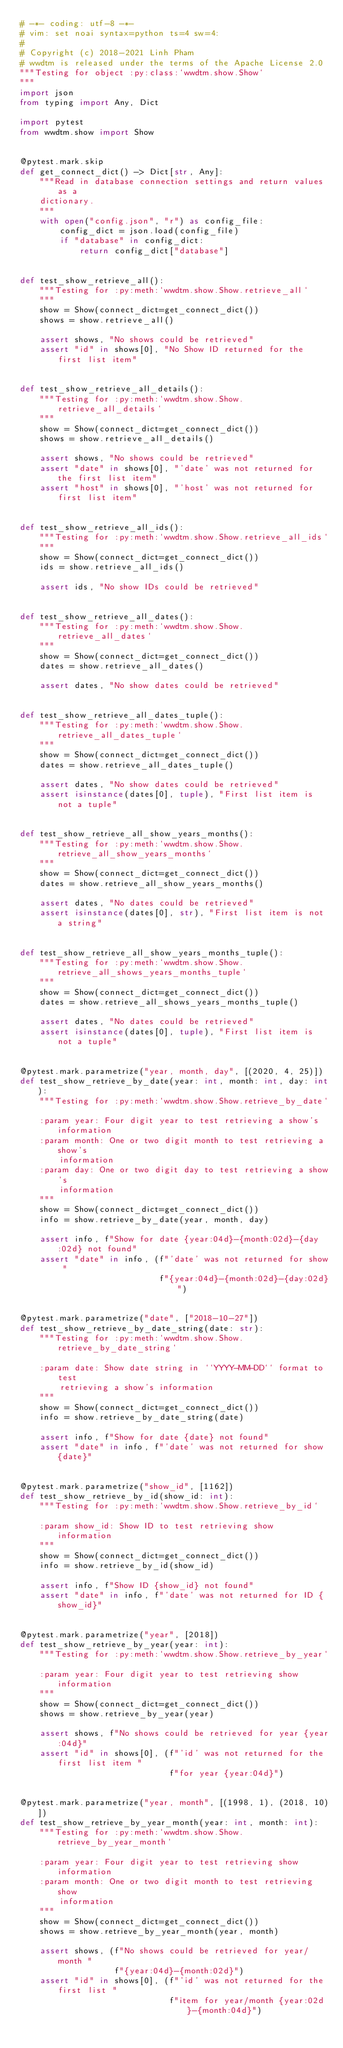<code> <loc_0><loc_0><loc_500><loc_500><_Python_># -*- coding: utf-8 -*-
# vim: set noai syntax=python ts=4 sw=4:
#
# Copyright (c) 2018-2021 Linh Pham
# wwdtm is released under the terms of the Apache License 2.0
"""Testing for object :py:class:`wwdtm.show.Show`
"""
import json
from typing import Any, Dict

import pytest
from wwdtm.show import Show


@pytest.mark.skip
def get_connect_dict() -> Dict[str, Any]:
    """Read in database connection settings and return values as a
    dictionary.
    """
    with open("config.json", "r") as config_file:
        config_dict = json.load(config_file)
        if "database" in config_dict:
            return config_dict["database"]


def test_show_retrieve_all():
    """Testing for :py:meth:`wwdtm.show.Show.retrieve_all`
    """
    show = Show(connect_dict=get_connect_dict())
    shows = show.retrieve_all()

    assert shows, "No shows could be retrieved"
    assert "id" in shows[0], "No Show ID returned for the first list item"


def test_show_retrieve_all_details():
    """Testing for :py:meth:`wwdtm.show.Show.retrieve_all_details`
    """
    show = Show(connect_dict=get_connect_dict())
    shows = show.retrieve_all_details()

    assert shows, "No shows could be retrieved"
    assert "date" in shows[0], "'date' was not returned for the first list item"
    assert "host" in shows[0], "'host' was not returned for first list item"


def test_show_retrieve_all_ids():
    """Testing for :py:meth:`wwdtm.show.Show.retrieve_all_ids`
    """
    show = Show(connect_dict=get_connect_dict())
    ids = show.retrieve_all_ids()

    assert ids, "No show IDs could be retrieved"


def test_show_retrieve_all_dates():
    """Testing for :py:meth:`wwdtm.show.Show.retrieve_all_dates`
    """
    show = Show(connect_dict=get_connect_dict())
    dates = show.retrieve_all_dates()

    assert dates, "No show dates could be retrieved"


def test_show_retrieve_all_dates_tuple():
    """Testing for :py:meth:`wwdtm.show.Show.retrieve_all_dates_tuple`
    """
    show = Show(connect_dict=get_connect_dict())
    dates = show.retrieve_all_dates_tuple()

    assert dates, "No show dates could be retrieved"
    assert isinstance(dates[0], tuple), "First list item is not a tuple"


def test_show_retrieve_all_show_years_months():
    """Testing for :py:meth:`wwdtm.show.Show.retrieve_all_show_years_months`
    """
    show = Show(connect_dict=get_connect_dict())
    dates = show.retrieve_all_show_years_months()

    assert dates, "No dates could be retrieved"
    assert isinstance(dates[0], str), "First list item is not a string"


def test_show_retrieve_all_show_years_months_tuple():
    """Testing for :py:meth:`wwdtm.show.Show.retrieve_all_shows_years_months_tuple`
    """
    show = Show(connect_dict=get_connect_dict())
    dates = show.retrieve_all_shows_years_months_tuple()

    assert dates, "No dates could be retrieved"
    assert isinstance(dates[0], tuple), "First list item is not a tuple"


@pytest.mark.parametrize("year, month, day", [(2020, 4, 25)])
def test_show_retrieve_by_date(year: int, month: int, day: int):
    """Testing for :py:meth:`wwdtm.show.Show.retrieve_by_date`

    :param year: Four digit year to test retrieving a show's information
    :param month: One or two digit month to test retrieving a show's
        information
    :param day: One or two digit day to test retrieving a show's
        information
    """
    show = Show(connect_dict=get_connect_dict())
    info = show.retrieve_by_date(year, month, day)

    assert info, f"Show for date {year:04d}-{month:02d}-{day:02d} not found"
    assert "date" in info, (f"'date' was not returned for show "
                            f"{year:04d}-{month:02d}-{day:02d}")


@pytest.mark.parametrize("date", ["2018-10-27"])
def test_show_retrieve_by_date_string(date: str):
    """Testing for :py:meth:`wwdtm.show.Show.retrieve_by_date_string`

    :param date: Show date string in ``YYYY-MM-DD`` format to test
        retrieving a show's information
    """
    show = Show(connect_dict=get_connect_dict())
    info = show.retrieve_by_date_string(date)

    assert info, f"Show for date {date} not found"
    assert "date" in info, f"'date' was not returned for show {date}"


@pytest.mark.parametrize("show_id", [1162])
def test_show_retrieve_by_id(show_id: int):
    """Testing for :py:meth:`wwdtm.show.Show.retrieve_by_id`

    :param show_id: Show ID to test retrieving show information
    """
    show = Show(connect_dict=get_connect_dict())
    info = show.retrieve_by_id(show_id)

    assert info, f"Show ID {show_id} not found"
    assert "date" in info, f"'date' was not returned for ID {show_id}"


@pytest.mark.parametrize("year", [2018])
def test_show_retrieve_by_year(year: int):
    """Testing for :py:meth:`wwdtm.show.Show.retrieve_by_year`

    :param year: Four digit year to test retrieving show information
    """
    show = Show(connect_dict=get_connect_dict())
    shows = show.retrieve_by_year(year)

    assert shows, f"No shows could be retrieved for year {year:04d}"
    assert "id" in shows[0], (f"'id' was not returned for the first list item "
                              f"for year {year:04d}")


@pytest.mark.parametrize("year, month", [(1998, 1), (2018, 10)])
def test_show_retrieve_by_year_month(year: int, month: int):
    """Testing for :py:meth:`wwdtm.show.Show.retrieve_by_year_month`

    :param year: Four digit year to test retrieving show information
    :param month: One or two digit month to test retrieving show
        information
    """
    show = Show(connect_dict=get_connect_dict())
    shows = show.retrieve_by_year_month(year, month)

    assert shows, (f"No shows could be retrieved for year/month "
                   f"{year:04d}-{month:02d}")
    assert "id" in shows[0], (f"'id' was not returned for the first list "
                              f"item for year/month {year:02d}-{month:04d}")

</code> 